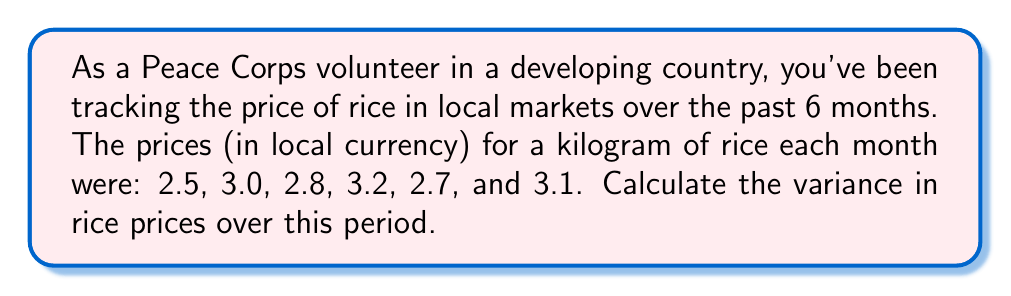Solve this math problem. To calculate the variance, we'll follow these steps:

1) First, calculate the mean price:
   $\mu = \frac{2.5 + 3.0 + 2.8 + 3.2 + 2.7 + 3.1}{6} = \frac{17.3}{6} = 2.883$

2) Next, calculate the squared differences from the mean:
   $(2.5 - 2.883)^2 = 0.147^2 = 0.0216$
   $(3.0 - 2.883)^2 = 0.117^2 = 0.0137$
   $(2.8 - 2.883)^2 = (-0.083)^2 = 0.0069$
   $(3.2 - 2.883)^2 = 0.317^2 = 0.1004$
   $(2.7 - 2.883)^2 = (-0.183)^2 = 0.0335$
   $(3.1 - 2.883)^2 = 0.217^2 = 0.0471$

3) Sum these squared differences:
   $0.0216 + 0.0137 + 0.0069 + 0.1004 + 0.0335 + 0.0471 = 0.2232$

4) Divide by the number of observations (6) to get the variance:
   $\text{Variance} = \frac{0.2232}{6} = 0.0372$

Therefore, the variance in rice prices over the 6-month period is 0.0372.
Answer: 0.0372 